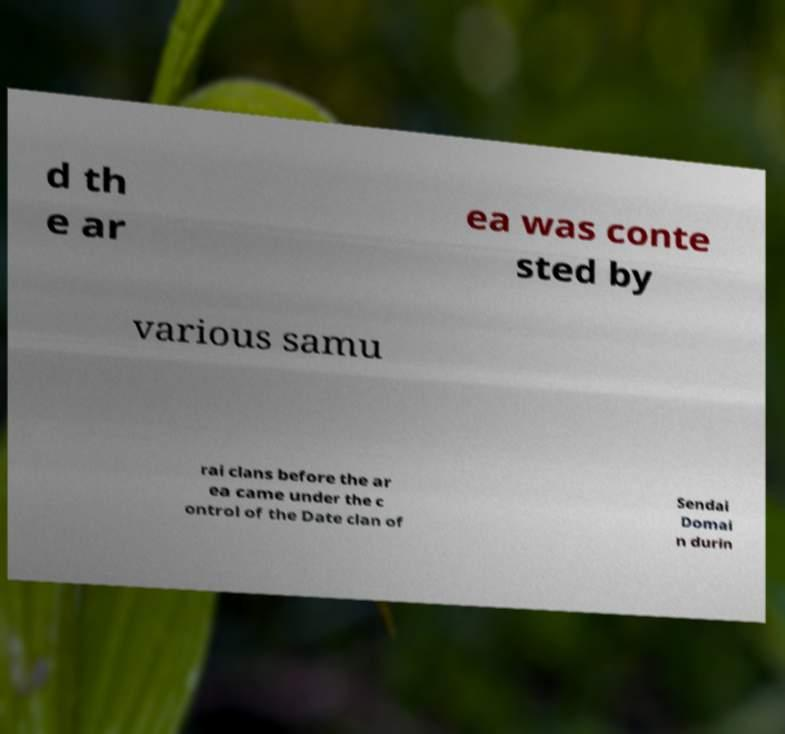There's text embedded in this image that I need extracted. Can you transcribe it verbatim? d th e ar ea was conte sted by various samu rai clans before the ar ea came under the c ontrol of the Date clan of Sendai Domai n durin 